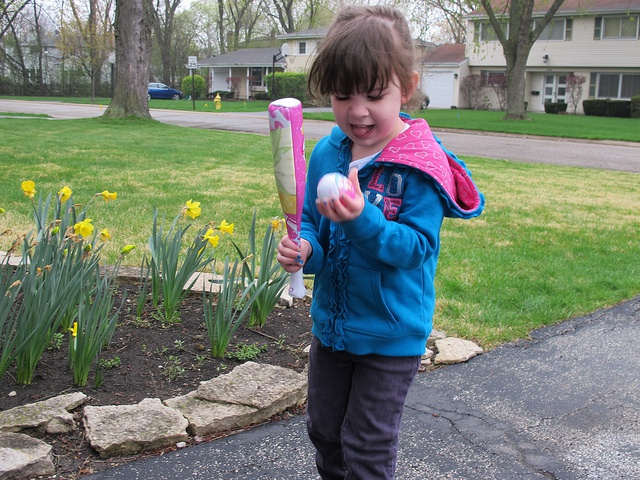Describe the objects in this image and their specific colors. I can see people in gray, black, navy, and blue tones, baseball bat in gray, darkgray, violet, olive, and magenta tones, sports ball in gray, lavender, violet, darkgray, and lightblue tones, car in gray, navy, and black tones, and fire hydrant in gray, olive, khaki, and tan tones in this image. 